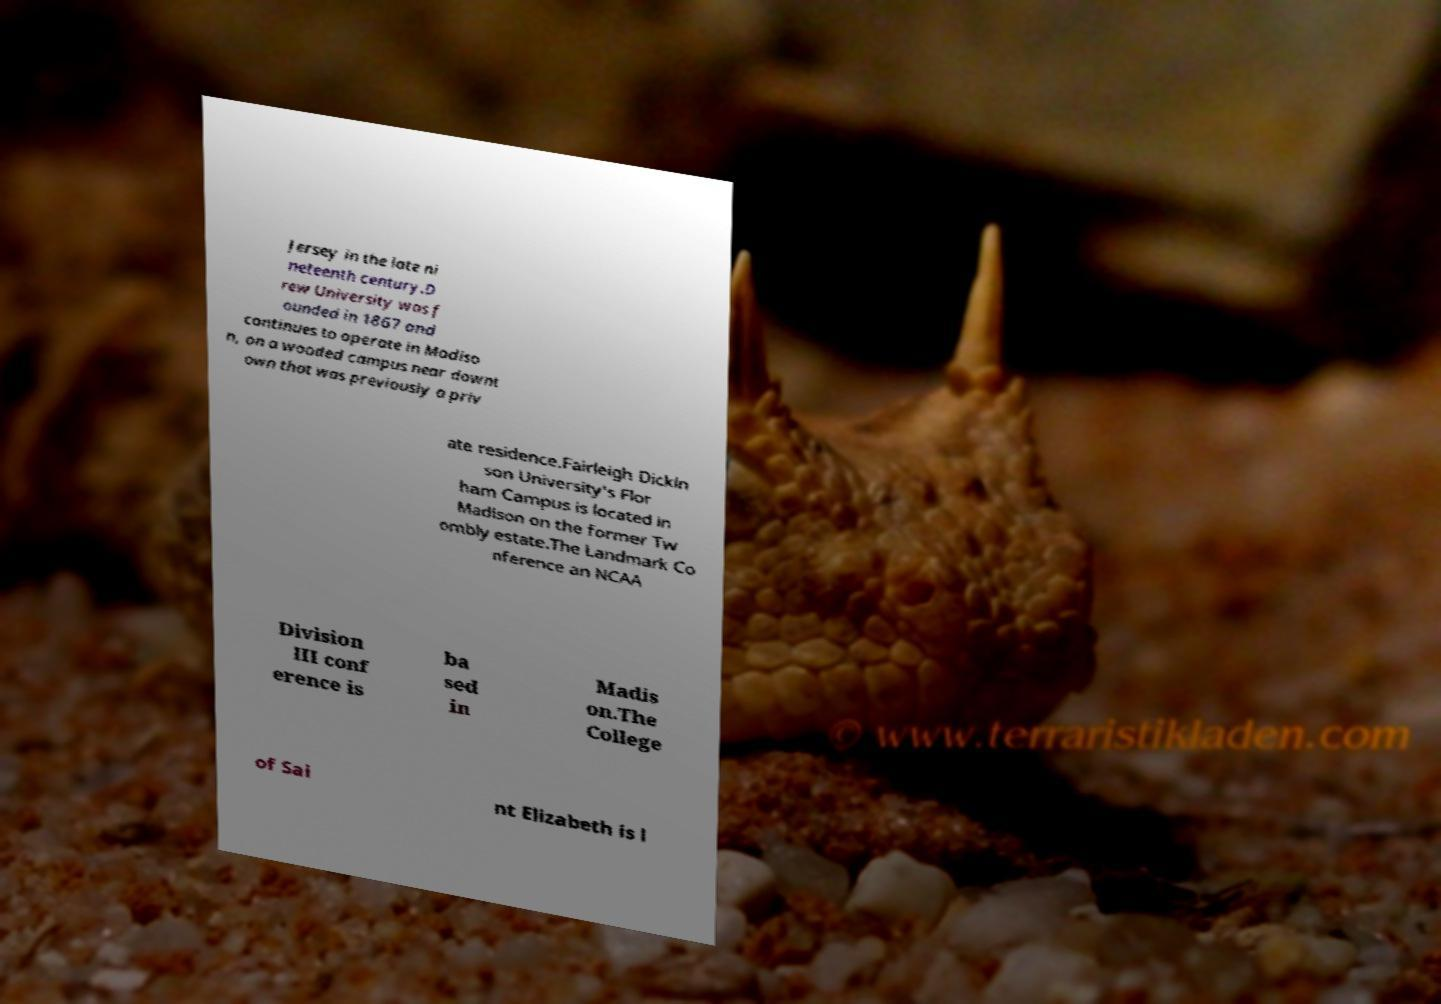What messages or text are displayed in this image? I need them in a readable, typed format. Jersey in the late ni neteenth century.D rew University was f ounded in 1867 and continues to operate in Madiso n, on a wooded campus near downt own that was previously a priv ate residence.Fairleigh Dickin son University's Flor ham Campus is located in Madison on the former Tw ombly estate.The Landmark Co nference an NCAA Division III conf erence is ba sed in Madis on.The College of Sai nt Elizabeth is l 